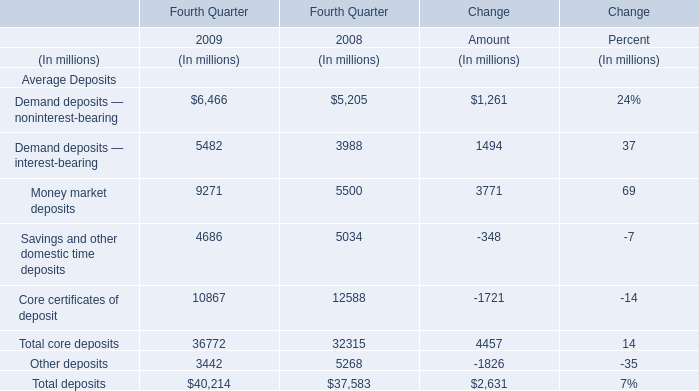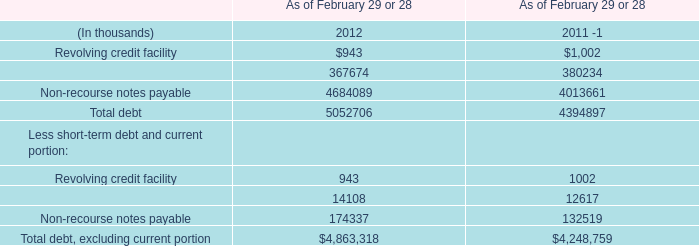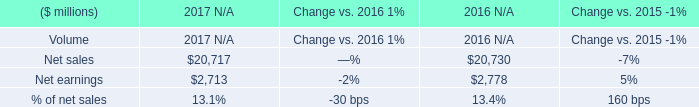In what year is Demand deposits — noninterest-bearing greater than 5000? 
Answer: 2008,2009. 